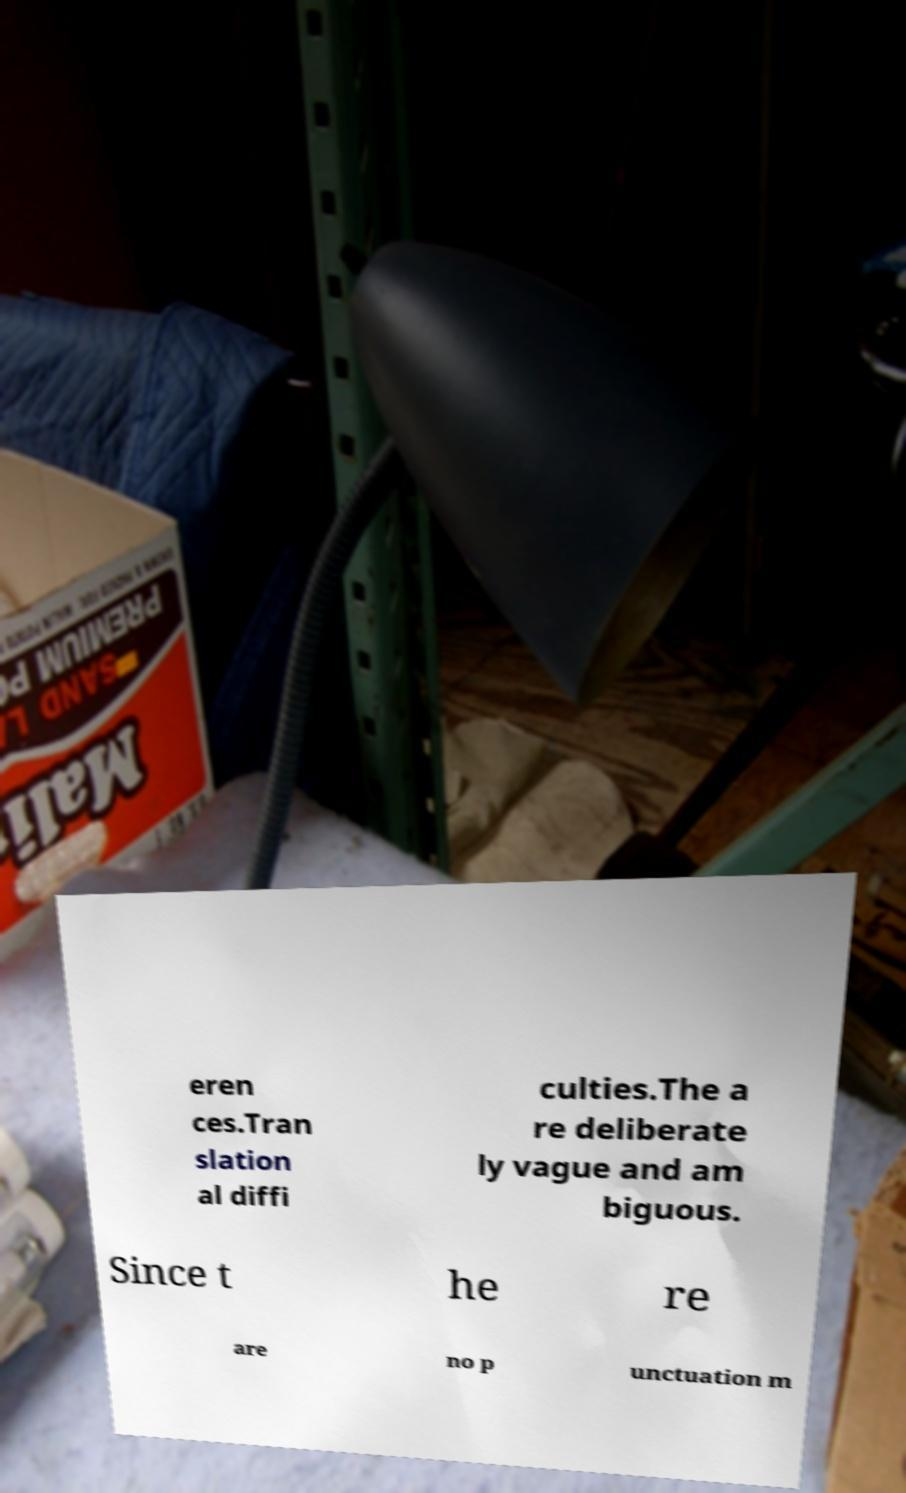Can you accurately transcribe the text from the provided image for me? eren ces.Tran slation al diffi culties.The a re deliberate ly vague and am biguous. Since t he re are no p unctuation m 